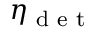<formula> <loc_0><loc_0><loc_500><loc_500>\eta _ { d e t }</formula> 